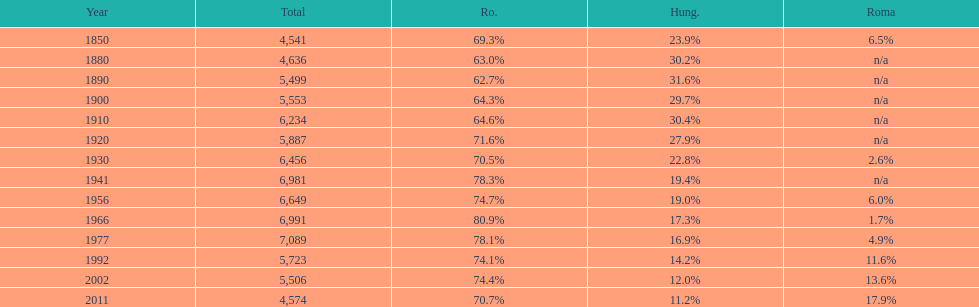What year had the highest total number? 1977. 